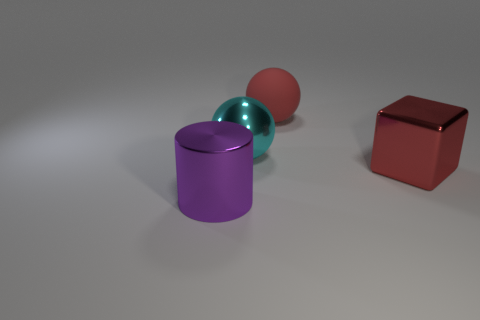Is there anything else that is the same material as the red sphere?
Give a very brief answer. No. Is there anything else that is the same color as the large matte ball?
Offer a very short reply. Yes. Are there more large spheres that are in front of the big rubber sphere than small yellow matte cylinders?
Ensure brevity in your answer.  Yes. What material is the red ball?
Offer a terse response. Rubber. What number of yellow shiny blocks have the same size as the purple thing?
Your answer should be compact. 0. Are there an equal number of big purple cylinders behind the big cyan shiny object and red metal blocks in front of the red metallic object?
Provide a short and direct response. Yes. Do the red ball and the cyan ball have the same material?
Your answer should be compact. No. There is a large object on the right side of the red rubber object; is there a thing in front of it?
Provide a succinct answer. Yes. Are there any other big things that have the same shape as the matte thing?
Provide a short and direct response. Yes. Does the block have the same color as the matte ball?
Keep it short and to the point. Yes. 